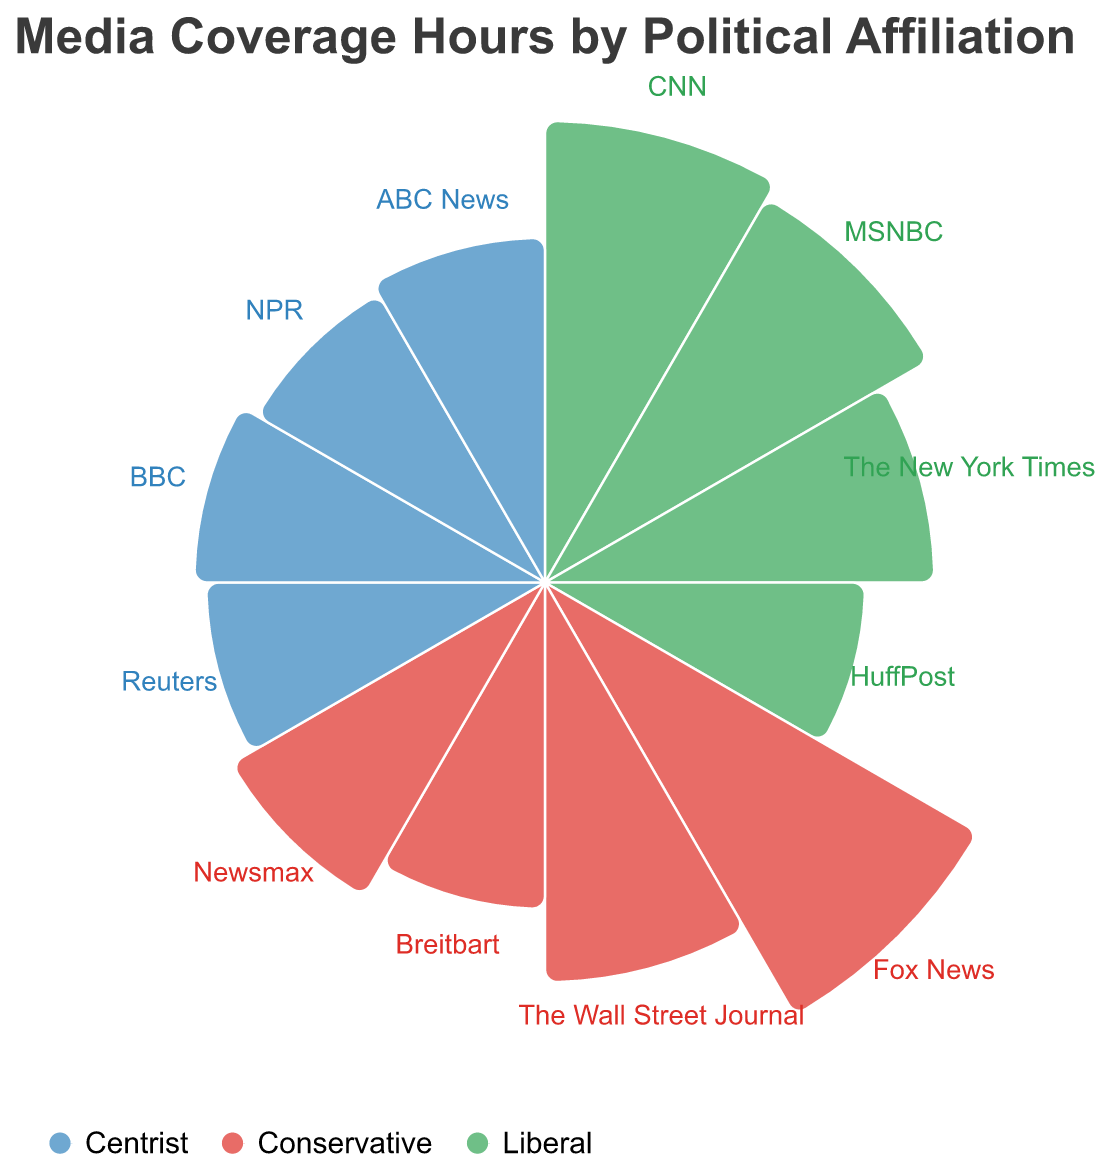What's the title of the figure? The title is displayed at the top of the figure which reads: "Media Coverage Hours by Political Affiliation".
Answer: Media Coverage Hours by Political Affiliation How many media outlets are represented on the chart? The chart labels a total of 12 different media outlets around its circumference.
Answer: 12 Which media outlet has the highest daily coverage hours? The radius corresponding to Fox News is the longest, representing the highest daily coverage hours among the media outlets.
Answer: Fox News Compare Fox News and CNN. Which one has more daily coverage hours and by how much? Fox News has a radius of 6.1, and CNN has a radius of 5.2. The difference is 6.1 - 5.2 = 0.9.
Answer: Fox News by 0.9 hours Which centrist media outlet has the highest daily coverage hours? Among the centrist outlets (Reuters, BBC, NPR, ABC News), BBC has the longest radius representing 3.0 daily coverage hours.
Answer: BBC What is the total daily coverage hours for all the liberal media outlets? Summing the daily coverage hours for CNN (5.2), MSNBC (4.8), The New York Times (3.7), and HuffPost (2.5) yields 5.2 + 4.8 + 3.7 + 2.5 = 16.2.
Answer: 16.2 Which political affiliation has the most total daily coverage hours? Summing up all the daily coverage hours for liberal, conservative, and centrist media: Liberals (16.2), Conservatives (6.1 + 3.9 + 2.6 + 3.2 = 15.8), and Centrists (2.8 + 3.0 + 2.7 + 2.9 = 11.4) shows that Liberal has the most.
Answer: Liberal How do the total daily coverage hours of centrist media outlets compare to liberal ones? From previous calculations, liberals have 16.2 hours and centrists have 11.4 hours. 16.2 - 11.4 = 4.8, so liberals have 4.8 more hours.
Answer: Liberals have 4.8 more hours Identify the media outlet with the shortest daily coverage hours and state its political affiliation. HuffPost has the shortest daily coverage hours with a radius of 2.5, and it is affiliated with the Liberal party.
Answer: HuffPost, Liberal Is there a media outlet with a daily coverage between 2.5 and 3.0 hours in each political affiliation? Reviewing each affiliation: Liberal has HuffPost (2.5) and no others in the range, Conservatives have Breitbart (2.6), and Centrists have Reuters (2.8), NPR (2.7), ABC News (2.9). So, only Conservatives and Centrists do.
Answer: No 